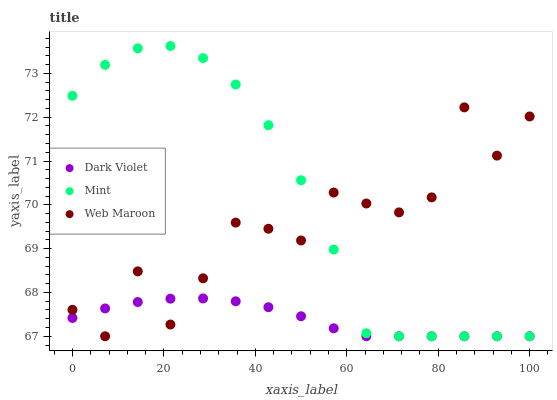Does Dark Violet have the minimum area under the curve?
Answer yes or no. Yes. Does Mint have the maximum area under the curve?
Answer yes or no. Yes. Does Mint have the minimum area under the curve?
Answer yes or no. No. Does Dark Violet have the maximum area under the curve?
Answer yes or no. No. Is Dark Violet the smoothest?
Answer yes or no. Yes. Is Web Maroon the roughest?
Answer yes or no. Yes. Is Mint the smoothest?
Answer yes or no. No. Is Mint the roughest?
Answer yes or no. No. Does Web Maroon have the lowest value?
Answer yes or no. Yes. Does Mint have the highest value?
Answer yes or no. Yes. Does Dark Violet have the highest value?
Answer yes or no. No. Does Mint intersect Dark Violet?
Answer yes or no. Yes. Is Mint less than Dark Violet?
Answer yes or no. No. Is Mint greater than Dark Violet?
Answer yes or no. No. 